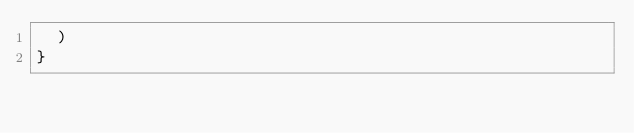<code> <loc_0><loc_0><loc_500><loc_500><_JavaScript_>  )
}
</code> 